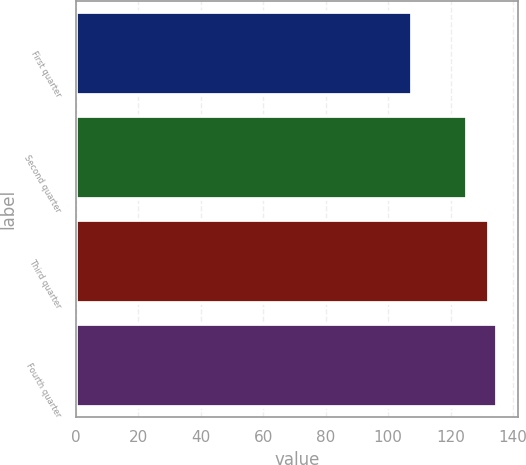<chart> <loc_0><loc_0><loc_500><loc_500><bar_chart><fcel>First quarter<fcel>Second quarter<fcel>Third quarter<fcel>Fourth quarter<nl><fcel>107.51<fcel>125.26<fcel>132.39<fcel>134.94<nl></chart> 